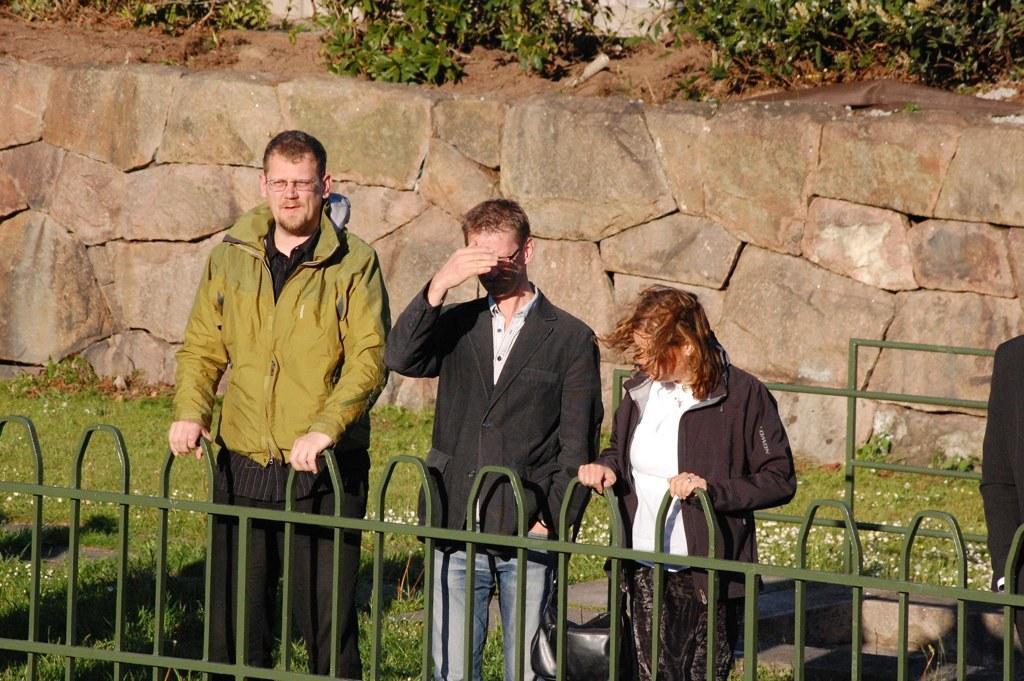How would you summarize this image in a sentence or two? There are people standing in the foreground area of the image in front of a boundary, there is another person on the right side, there are plants, grassland and a stone wall in the background. 